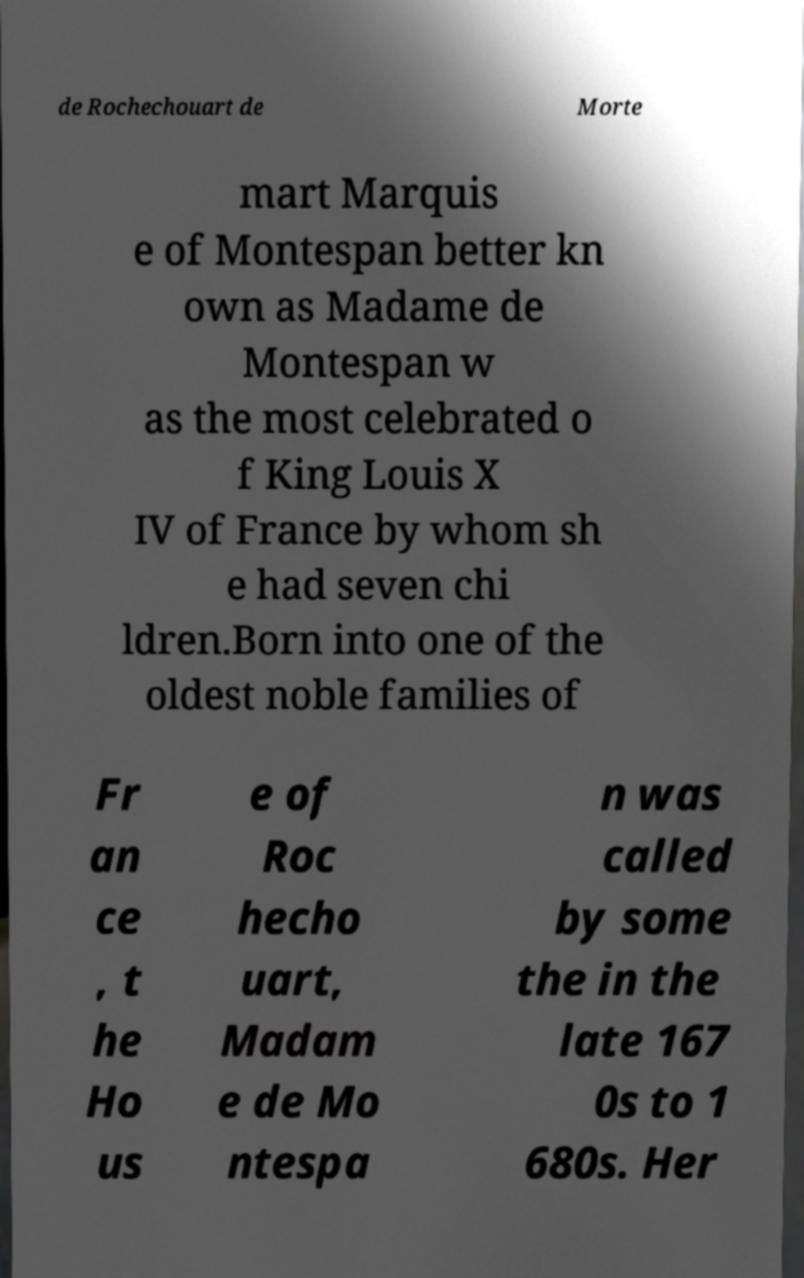Could you assist in decoding the text presented in this image and type it out clearly? de Rochechouart de Morte mart Marquis e of Montespan better kn own as Madame de Montespan w as the most celebrated o f King Louis X IV of France by whom sh e had seven chi ldren.Born into one of the oldest noble families of Fr an ce , t he Ho us e of Roc hecho uart, Madam e de Mo ntespa n was called by some the in the late 167 0s to 1 680s. Her 